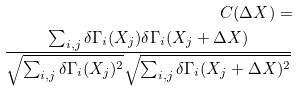<formula> <loc_0><loc_0><loc_500><loc_500>C ( \Delta X ) = \\ \frac { \sum _ { i , j } \delta \Gamma _ { i } ( X _ { j } ) \delta \Gamma _ { i } ( X _ { j } + \Delta X ) } { \sqrt { \sum _ { i , j } \delta \Gamma _ { i } ( X _ { j } ) ^ { 2 } } \sqrt { \sum _ { i , j } \delta \Gamma _ { i } ( X _ { j } + \Delta X ) ^ { 2 } } }</formula> 